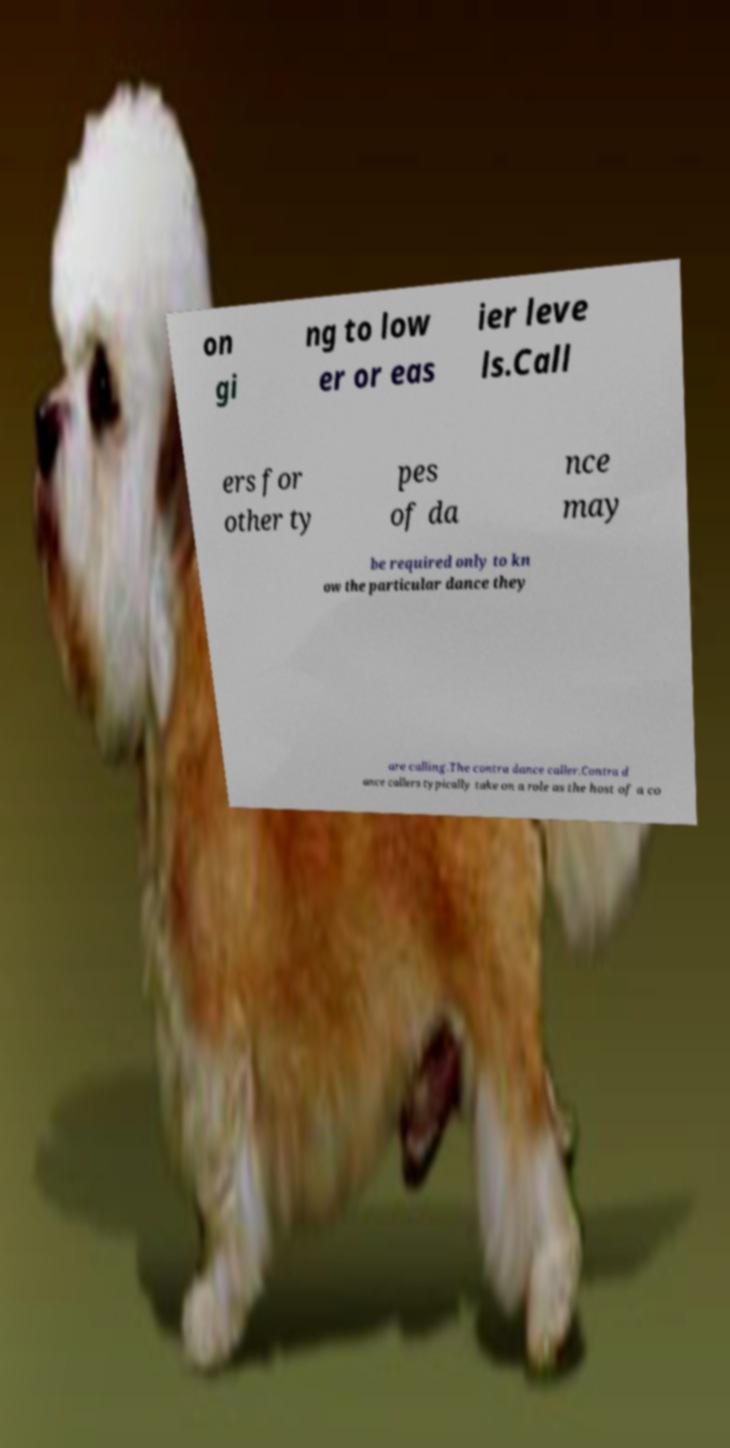Please identify and transcribe the text found in this image. on gi ng to low er or eas ier leve ls.Call ers for other ty pes of da nce may be required only to kn ow the particular dance they are calling.The contra dance caller.Contra d ance callers typically take on a role as the host of a co 